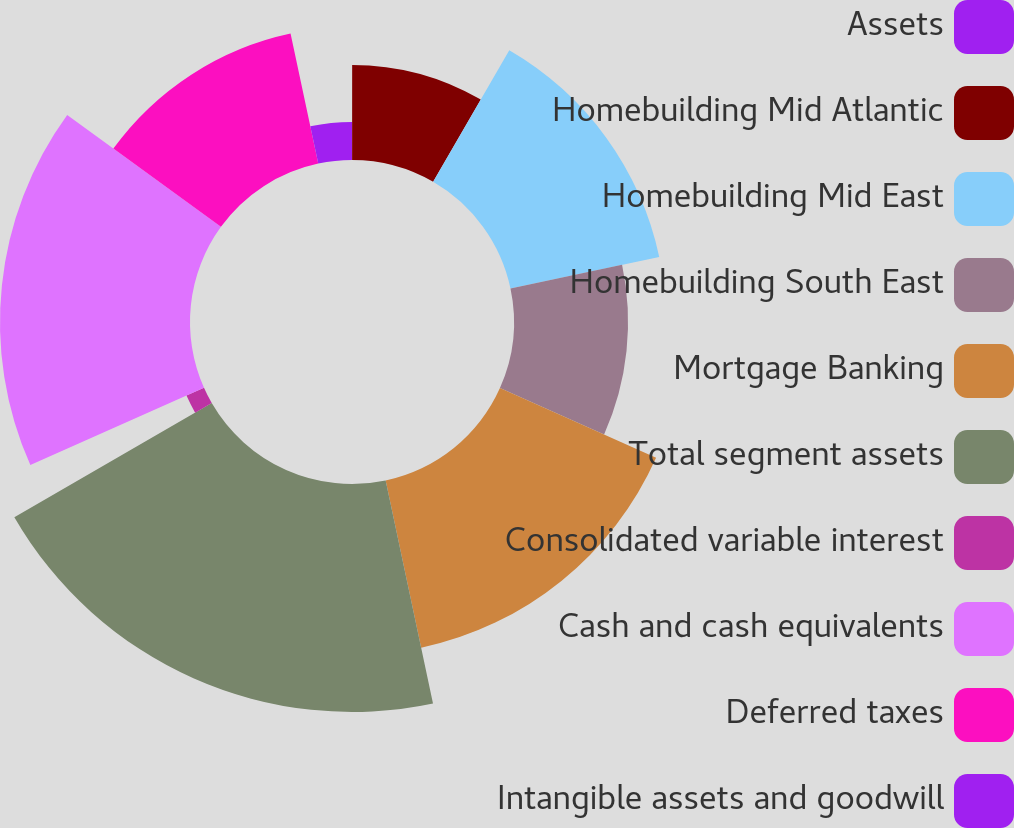<chart> <loc_0><loc_0><loc_500><loc_500><pie_chart><fcel>Assets<fcel>Homebuilding Mid Atlantic<fcel>Homebuilding Mid East<fcel>Homebuilding South East<fcel>Mortgage Banking<fcel>Total segment assets<fcel>Consolidated variable interest<fcel>Cash and cash equivalents<fcel>Deferred taxes<fcel>Intangible assets and goodwill<nl><fcel>0.01%<fcel>8.34%<fcel>13.33%<fcel>10.0%<fcel>14.99%<fcel>19.99%<fcel>1.68%<fcel>16.66%<fcel>11.66%<fcel>3.34%<nl></chart> 